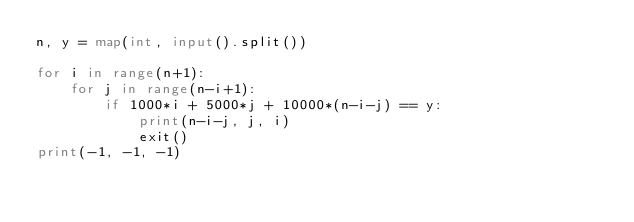<code> <loc_0><loc_0><loc_500><loc_500><_Python_>n, y = map(int, input().split())

for i in range(n+1):
    for j in range(n-i+1):
        if 1000*i + 5000*j + 10000*(n-i-j) == y:
            print(n-i-j, j, i)
            exit()
print(-1, -1, -1)

</code> 